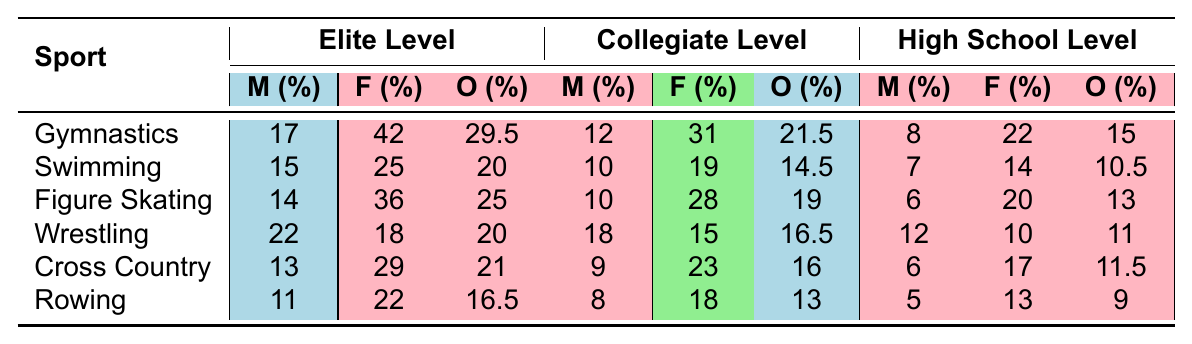What is the prevalence of eating disorders among female gymnasts at the elite level? According to the table, the prevalence of eating disorders among female gymnasts at the elite level is indicated as 42%.
Answer: 42% Which sport has the highest overall percentage of eating disorders at the elite level among male athletes? When comparing the overall percentages of eating disorders for male athletes at the elite level across sports, Wrestling has the highest value at 22%.
Answer: 22% What is the average percentage of eating disorders for female athletes across all sports at the collegiate level? To find the average, sum the percentages for female athletes at the collegiate level: (31 + 19 + 28 + 15 + 23 + 18) = 134. There are 6 sports, so the average is 134/6 ≈ 22.33%.
Answer: 22.33% Is the overall percentage of eating disorders among male rowers higher at the elite level compared to high school level? The overall percentage for male rowers at the elite level is 16.5%, while at the high school level it is 9%. Since 16.5% is greater than 9%, this statement is true.
Answer: Yes Which sport shows a greater increase in eating disorder prevalence among female athletes from the high school level to the elite level? The increase for each sport is calculated as the difference between the elite and high school levels for female athletes. Gymnastics shows an increase of 20% (42% - 22%), while Swimming shows an increase of 11% (25% - 14%). Hence, Gymnastics has a greater increase.
Answer: Gymnastics What is the overall prevalence of eating disorders among athletes in Cross Country at the collegiate level? The table states that the overall prevalence for athletes in Cross Country at the collegiate level is 16%.
Answer: 16% Among the sports listed, which one has the lowest percentage of eating disorders for female athletes at the high school level? Referring to the table, Rowing has the lowest percentage for female athletes at the high school level at 13%.
Answer: 13% How does the overall percentage of eating disorders among collegiate male athletes compare between Gymnastics and Wrestling? The overall percentage for collegiate male athletes in Gymnastics is 12% and for Wrestling, it is 18%. This indicates that collegiate male wrestlers have a higher prevalence of eating disorders.
Answer: Wrestling is higher 